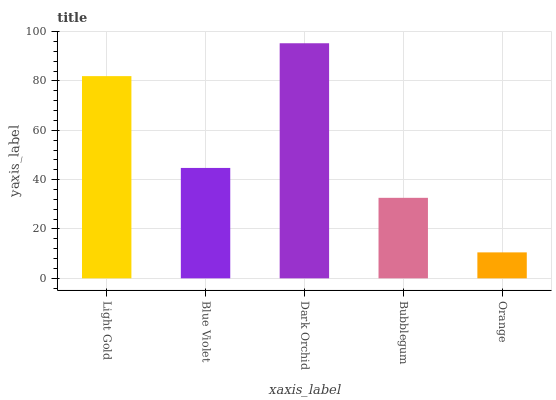Is Orange the minimum?
Answer yes or no. Yes. Is Dark Orchid the maximum?
Answer yes or no. Yes. Is Blue Violet the minimum?
Answer yes or no. No. Is Blue Violet the maximum?
Answer yes or no. No. Is Light Gold greater than Blue Violet?
Answer yes or no. Yes. Is Blue Violet less than Light Gold?
Answer yes or no. Yes. Is Blue Violet greater than Light Gold?
Answer yes or no. No. Is Light Gold less than Blue Violet?
Answer yes or no. No. Is Blue Violet the high median?
Answer yes or no. Yes. Is Blue Violet the low median?
Answer yes or no. Yes. Is Bubblegum the high median?
Answer yes or no. No. Is Dark Orchid the low median?
Answer yes or no. No. 